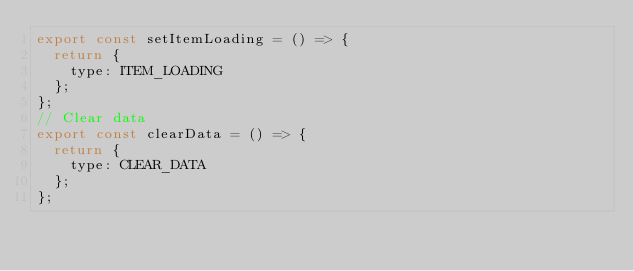<code> <loc_0><loc_0><loc_500><loc_500><_JavaScript_>export const setItemLoading = () => {
  return {
    type: ITEM_LOADING
  };
};
// Clear data
export const clearData = () => {
  return {
    type: CLEAR_DATA
  };
};
</code> 